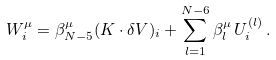Convert formula to latex. <formula><loc_0><loc_0><loc_500><loc_500>W _ { i } ^ { \mu } = \beta ^ { \mu } _ { N - 5 } ( K \cdot \delta V ) _ { i } + \sum _ { l = 1 } ^ { N - 6 } \beta ^ { \mu } _ { l } \, U _ { i } ^ { ( l ) } \, .</formula> 